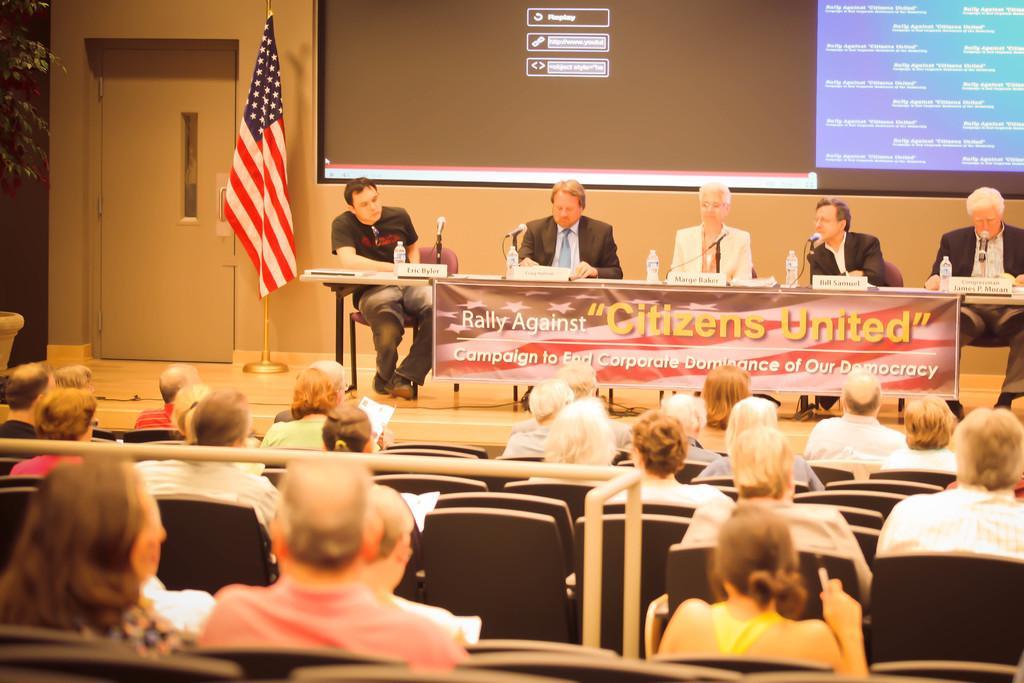How would you summarize this image in a sentence or two? In the image there are few people sitting on chairs in front of table with mics and water bottles on it in front of a screen with a flag on the left side and in the front there are many people sitting on chairs staring at the stage. 